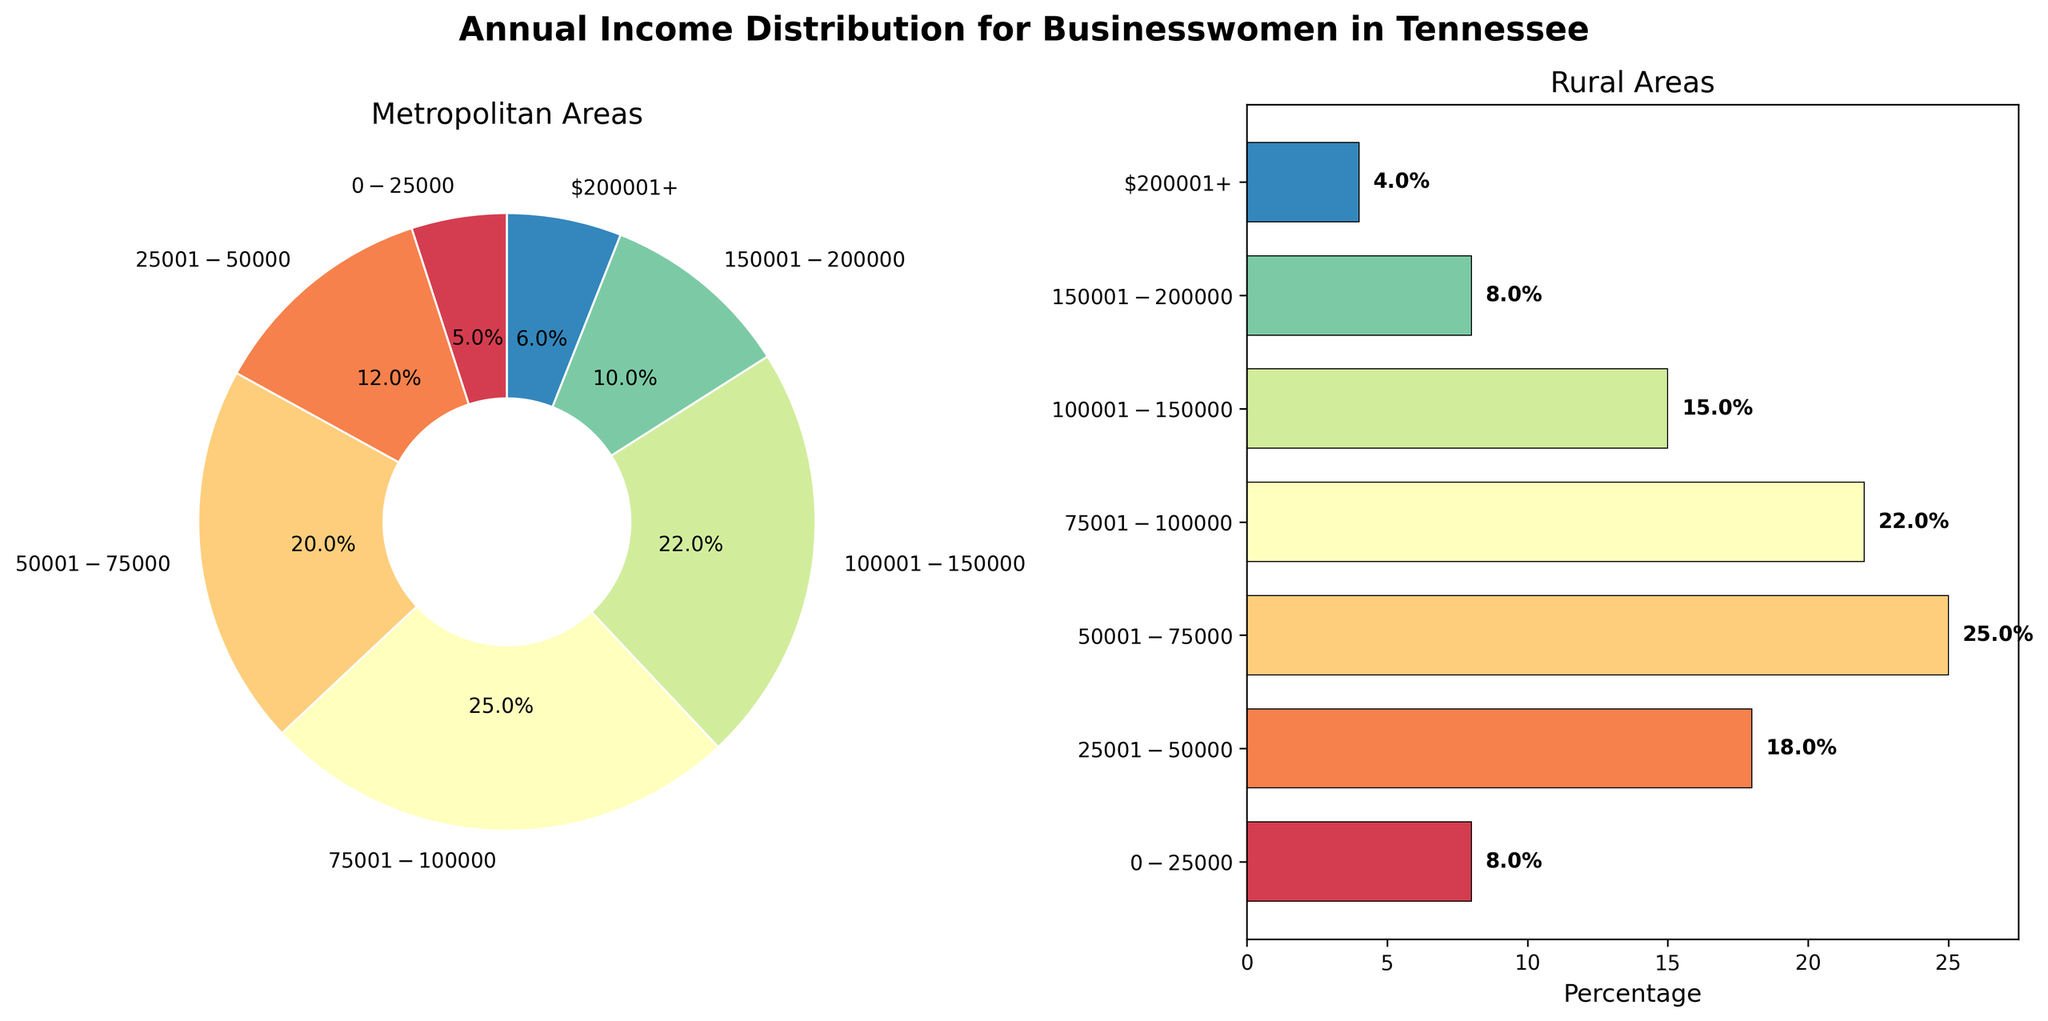What's the title of the figure? The title of the figure is displayed at the top and it is "Annual Income Distribution for Businesswomen in Tennessee".
Answer: Annual Income Distribution for Businesswomen in Tennessee What types of charts are used to represent the data? There are two types of charts used: a pie chart for Metropolitan Areas and a horizontal bar chart for Rural Areas.
Answer: Pie chart and horizontal bar chart Which income range has the highest percentage in Metropolitan Areas? Looking at the pie chart for Metropolitan Areas, the $75001-$100000 income range has the largest slice, which means it has the highest percentage.
Answer: $75001-$100000 Which income range has the lowest percentage in Rural Areas? Observing the horizontal bar chart for Rural Areas, the $200001+ income range has the shortest bar, indicating the lowest percentage.
Answer: $200001+ How does the percentage of businesswomen earning $100001-$150000 compare between Metropolitan and Rural Areas? The $100001-$150000 income range is 22% in Metropolitan Areas and 15% in Rural Areas, with Metropolitan Areas having a higher percentage.
Answer: Metropolitan Areas are higher What is the total percentage of businesswomen earning $0-$50000 in Rural Areas? Sum the percentages of the $0-$25000 and $25001-$50000 ranges in Rural Areas, which are 8% and 18% respectively. (8% + 18% = 26%)
Answer: 26% What is the percentage difference between the highest and lowest income ranges in Metropolitan Areas? The highest percentage in Metropolitan Areas is $75001-$100000 at 25% and the lowest is $200001+ at 6%. (25% - 6% = 19%)
Answer: 19% Which income range has a higher percentage in Rural Areas compared to Metropolitan Areas? Comparing both charts, the $50001-$75000 and $25001-$50000 income ranges have higher percentages in Rural Areas compared to Metropolitan Areas.
Answer: $50001-$75000 and $25001-$50000 What is the combined percentage of businesswomen earning $150001+ in Metropolitan Areas? Add the percentages for the $150001-$200000 and $200001+ income ranges in Metropolitan Areas: (10% + 6% = 16%)
Answer: 16% In which area do more businesswomen earn below $100000, Metropolitan or Rural? Sum the percentages of all income ranges below $100000 for both areas. Metropolitan: (5% + 12% + 20% + 25% = 62%), Rural: (8% + 18% + 25% + 22% = 73%). The Rural Areas have a higher percentage.
Answer: Rural Areas 